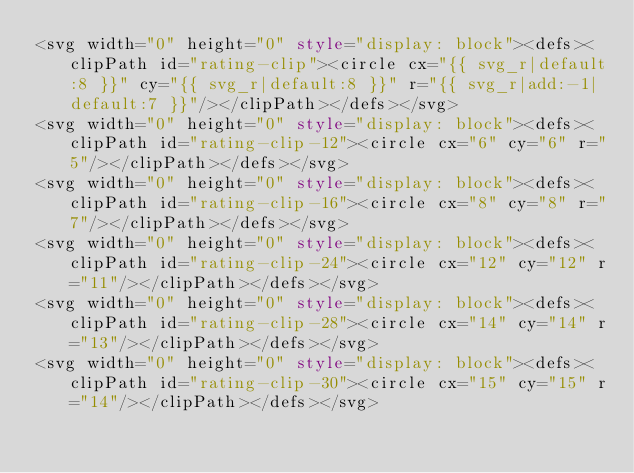<code> <loc_0><loc_0><loc_500><loc_500><_HTML_><svg width="0" height="0" style="display: block"><defs><clipPath id="rating-clip"><circle cx="{{ svg_r|default:8 }}" cy="{{ svg_r|default:8 }}" r="{{ svg_r|add:-1|default:7 }}"/></clipPath></defs></svg>
<svg width="0" height="0" style="display: block"><defs><clipPath id="rating-clip-12"><circle cx="6" cy="6" r="5"/></clipPath></defs></svg>
<svg width="0" height="0" style="display: block"><defs><clipPath id="rating-clip-16"><circle cx="8" cy="8" r="7"/></clipPath></defs></svg>
<svg width="0" height="0" style="display: block"><defs><clipPath id="rating-clip-24"><circle cx="12" cy="12" r="11"/></clipPath></defs></svg>
<svg width="0" height="0" style="display: block"><defs><clipPath id="rating-clip-28"><circle cx="14" cy="14" r="13"/></clipPath></defs></svg>
<svg width="0" height="0" style="display: block"><defs><clipPath id="rating-clip-30"><circle cx="15" cy="15" r="14"/></clipPath></defs></svg>
</code> 